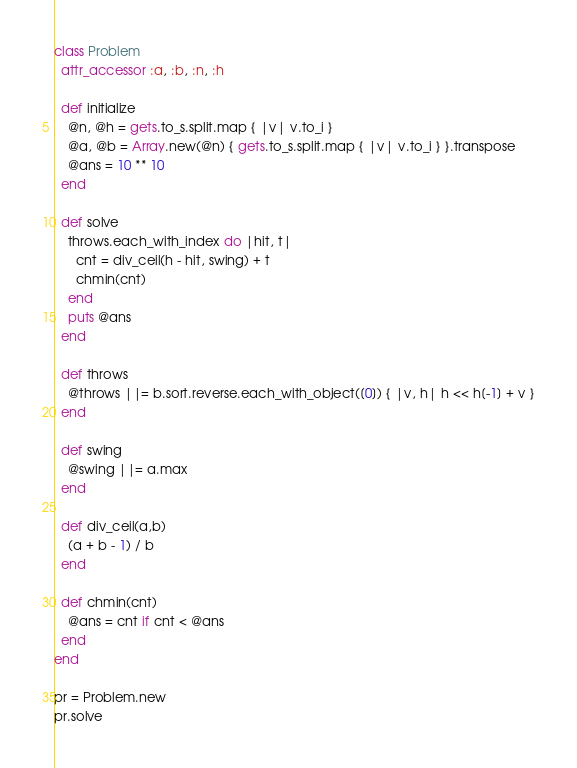<code> <loc_0><loc_0><loc_500><loc_500><_Ruby_>class Problem
  attr_accessor :a, :b, :n, :h

  def initialize
    @n, @h = gets.to_s.split.map { |v| v.to_i }
    @a, @b = Array.new(@n) { gets.to_s.split.map { |v| v.to_i } }.transpose
    @ans = 10 ** 10
  end

  def solve
    throws.each_with_index do |hit, t|
      cnt = div_ceil(h - hit, swing) + t
      chmin(cnt)
    end
    puts @ans
  end
  
  def throws
    @throws ||= b.sort.reverse.each_with_object([0]) { |v, h| h << h[-1] + v }
  end

  def swing
    @swing ||= a.max
  end

  def div_ceil(a,b)
    (a + b - 1) / b
  end

  def chmin(cnt)
    @ans = cnt if cnt < @ans
  end
end

pr = Problem.new
pr.solve
</code> 